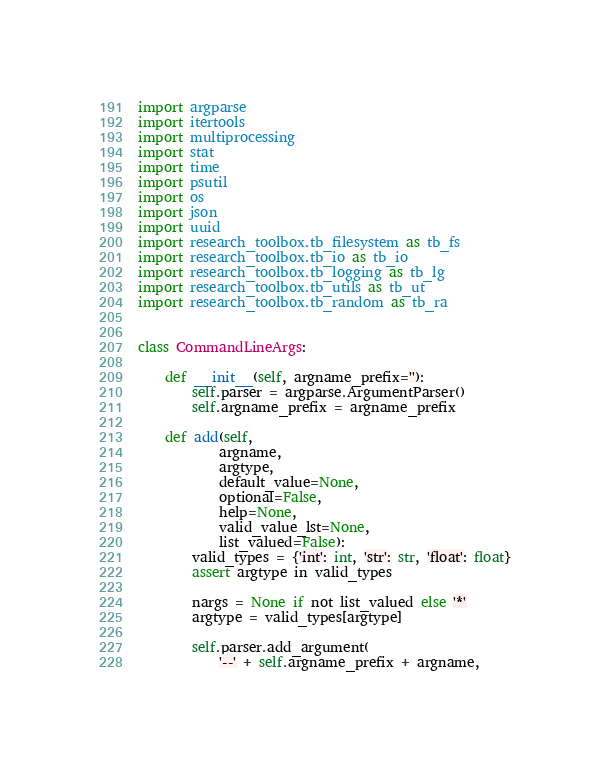<code> <loc_0><loc_0><loc_500><loc_500><_Python_>import argparse
import itertools
import multiprocessing
import stat
import time
import psutil
import os
import json
import uuid
import research_toolbox.tb_filesystem as tb_fs
import research_toolbox.tb_io as tb_io
import research_toolbox.tb_logging as tb_lg
import research_toolbox.tb_utils as tb_ut
import research_toolbox.tb_random as tb_ra


class CommandLineArgs:

    def __init__(self, argname_prefix=''):
        self.parser = argparse.ArgumentParser()
        self.argname_prefix = argname_prefix

    def add(self,
            argname,
            argtype,
            default_value=None,
            optional=False,
            help=None,
            valid_value_lst=None,
            list_valued=False):
        valid_types = {'int': int, 'str': str, 'float': float}
        assert argtype in valid_types

        nargs = None if not list_valued else '*'
        argtype = valid_types[argtype]

        self.parser.add_argument(
            '--' + self.argname_prefix + argname,</code> 